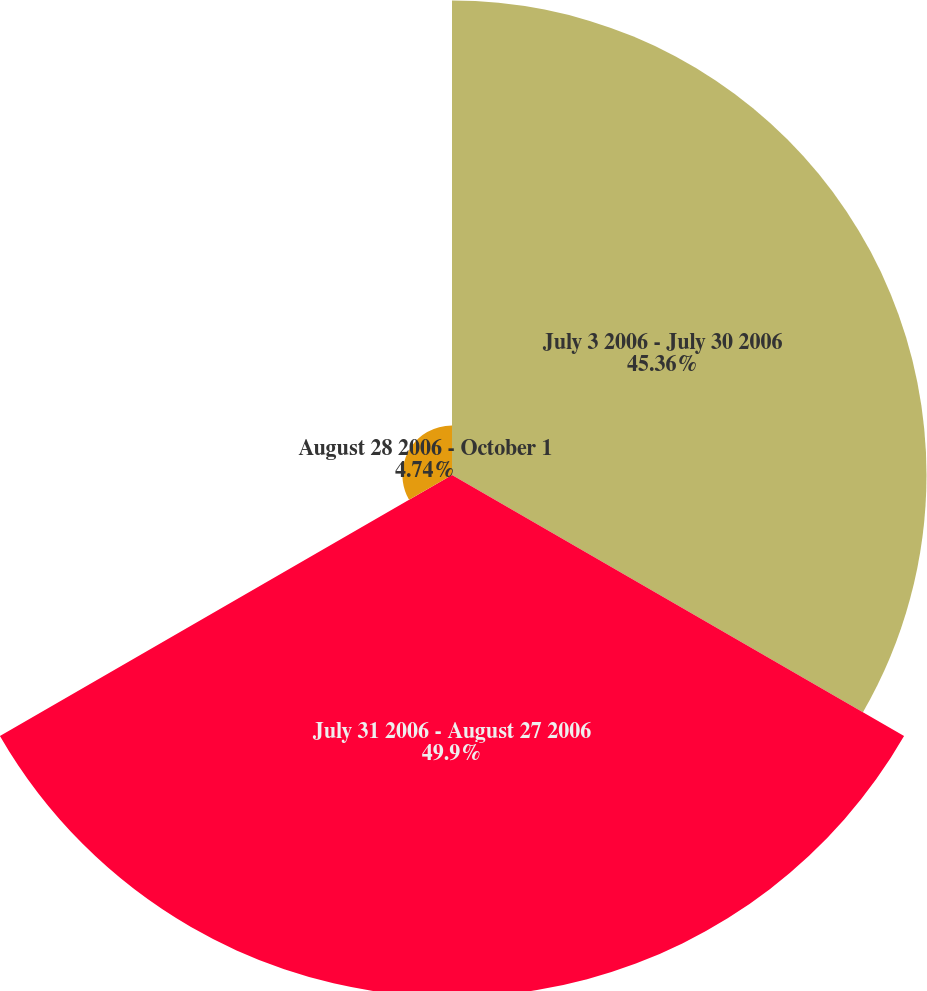<chart> <loc_0><loc_0><loc_500><loc_500><pie_chart><fcel>July 3 2006 - July 30 2006<fcel>July 31 2006 - August 27 2006<fcel>August 28 2006 - October 1<nl><fcel>45.36%<fcel>49.9%<fcel>4.74%<nl></chart> 